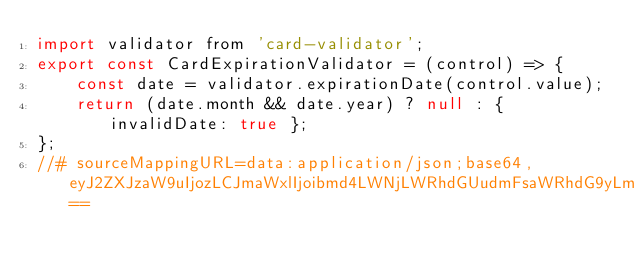Convert code to text. <code><loc_0><loc_0><loc_500><loc_500><_JavaScript_>import validator from 'card-validator';
export const CardExpirationValidator = (control) => {
    const date = validator.expirationDate(control.value);
    return (date.month && date.year) ? null : { invalidDate: true };
};
//# sourceMappingURL=data:application/json;base64,eyJ2ZXJzaW9uIjozLCJmaWxlIjoibmd4LWNjLWRhdGUudmFsaWRhdG9yLmpzIiwic291cmNlUm9vdCI6IiIsInNvdXJjZXMiOlsiLi4vLi4vLi4vLi4vLi4vcHJvamVjdHMvbmd4LWNjL3NyYy9saWIvdmFsaWRhdG9ycy9uZ3gtY2MtZGF0ZS52YWxpZGF0b3IudHMiXSwibmFtZXMiOltdLCJtYXBwaW5ncyI6IkFBQ0EsT0FBTyxTQUFTLE1BQU0sZ0JBQWdCLENBQUM7QUFFdkMsTUFBTSxDQUFDLE1BQU0sdUJBQXVCLEdBQUcsQ0FBQyxPQUFvQixFQUFFLEVBQUU7SUFDNUQsTUFBTSxJQUFJLEdBQUcsU0FBUyxDQUFDLGNBQWMsQ0FBQyxPQUFPLENBQUMsS0FBSyxDQUFDLENBQUM7SUFDckQsT0FBTyxDQUFDLElBQUksQ0FBQyxLQUFLLElBQUksSUFBSSxDQUFDLElBQUksQ0FBQyxDQUFDLENBQUMsQ0FBQyxJQUFJLENBQUMsQ0FBQyxDQUFDLEVBQUUsV0FBVyxFQUFFLElBQUksRUFBRSxDQUFDO0FBQ3BFLENBQUMsQ0FBQyIsInNvdXJjZXNDb250ZW50IjpbImltcG9ydCB7IEZvcm1Db250cm9sIH0gZnJvbSAnQGFuZ3VsYXIvZm9ybXMnO1xuaW1wb3J0IHZhbGlkYXRvciBmcm9tICdjYXJkLXZhbGlkYXRvcic7XG5cbmV4cG9ydCBjb25zdCBDYXJkRXhwaXJhdGlvblZhbGlkYXRvciA9IChjb250cm9sOiBGb3JtQ29udHJvbCkgPT4ge1xuICAgIGNvbnN0IGRhdGUgPSB2YWxpZGF0b3IuZXhwaXJhdGlvbkRhdGUoY29udHJvbC52YWx1ZSk7XG4gICAgcmV0dXJuIChkYXRlLm1vbnRoICYmIGRhdGUueWVhcikgPyBudWxsIDogeyBpbnZhbGlkRGF0ZTogdHJ1ZSB9O1xufTtcbiJdfQ==</code> 